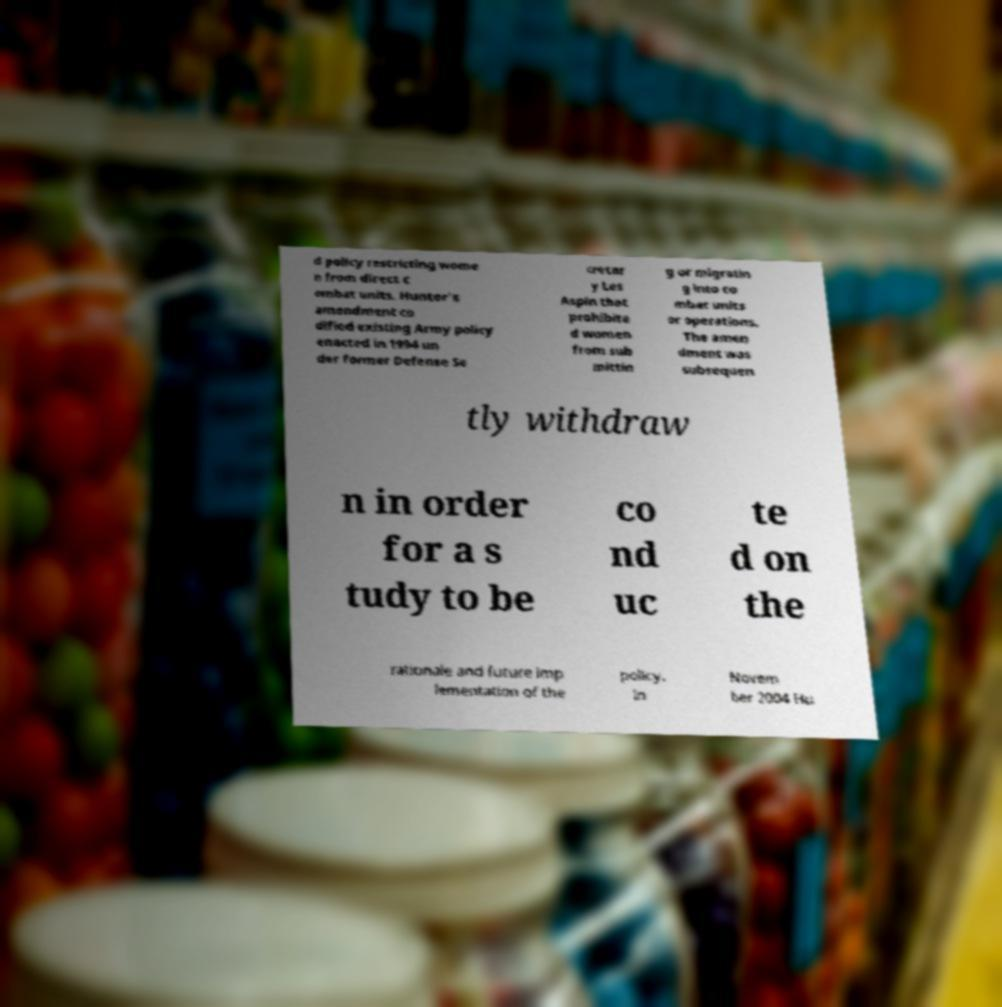Please read and relay the text visible in this image. What does it say? d policy restricting wome n from direct c ombat units. Hunter's amendment co dified existing Army policy enacted in 1994 un der former Defense Se cretar y Les Aspin that prohibite d women from sub mittin g or migratin g into co mbat units or operations. The amen dment was subsequen tly withdraw n in order for a s tudy to be co nd uc te d on the rationale and future imp lementation of the policy. In Novem ber 2004 Hu 